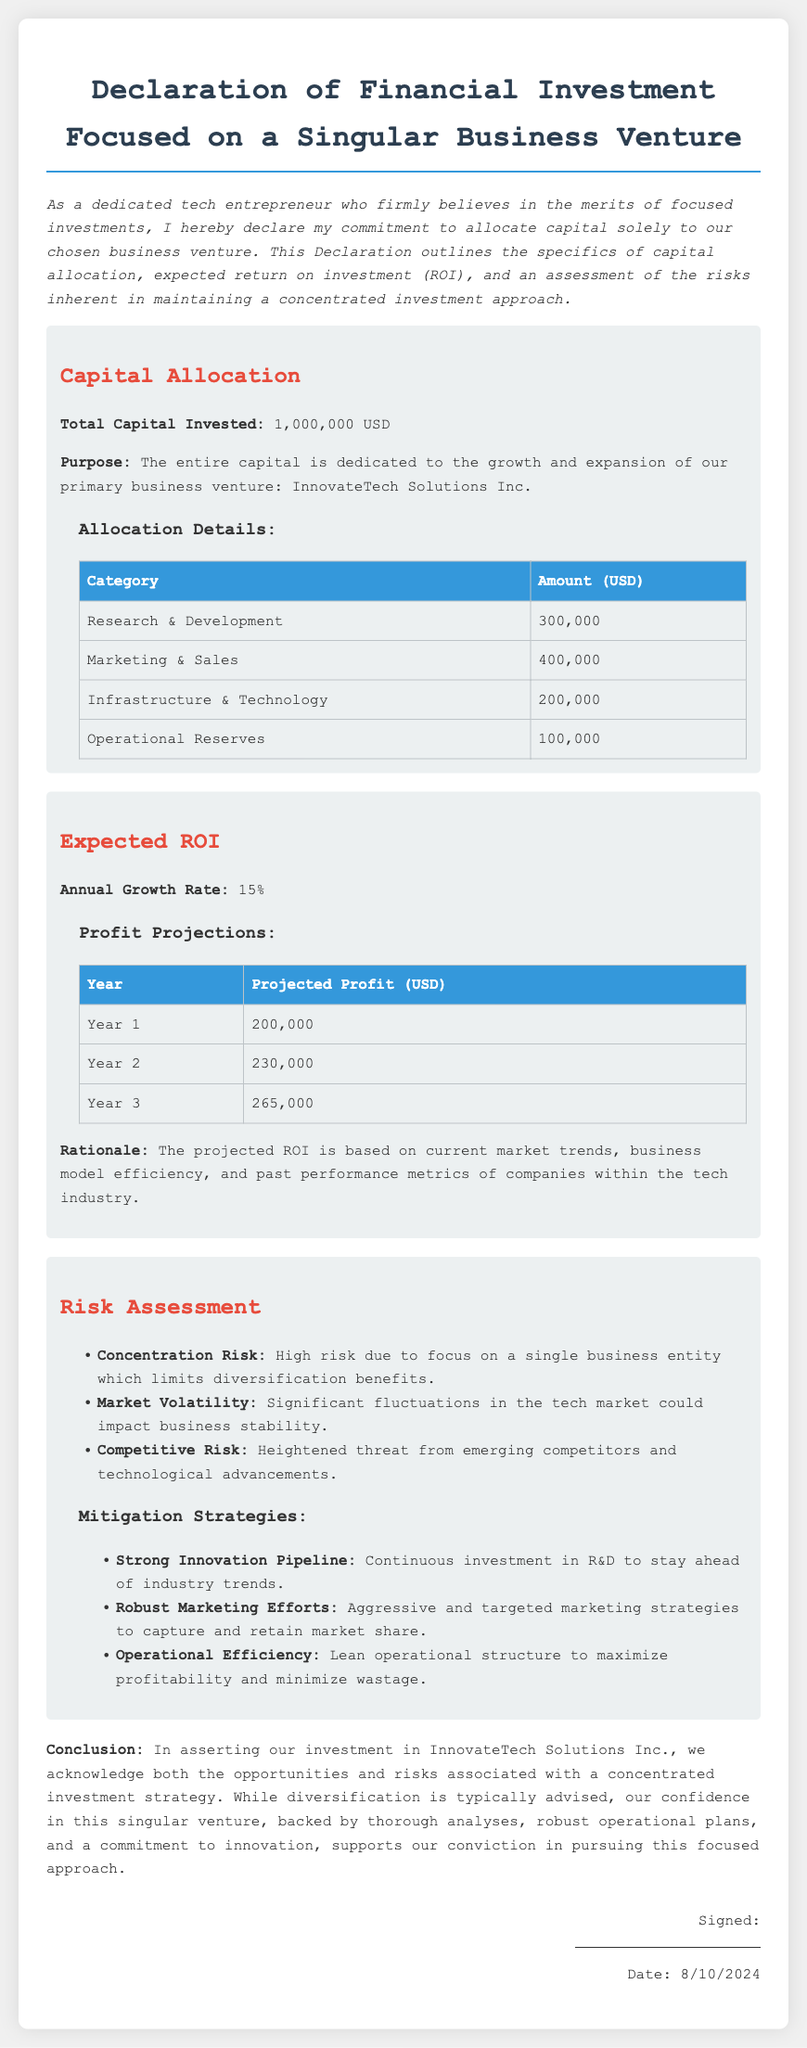What is the total capital invested? The total capital invested is stated explicitly in the document.
Answer: 1,000,000 USD How much is allocated to Research & Development? The allocation details include specific amounts for each category, with R&D listed.
Answer: 300,000 USD What is the expected annual growth rate? The document mentions an annual growth rate that is a key performance indicator for the investment.
Answer: 15% What is the projected profit in Year 2? The profit projections table lists expected profits for each year, including Year 2.
Answer: 230,000 USD What is the main purpose of the capital allocation? The purpose of the capital allocation is clearly defined in the introduction section of the document.
Answer: Growth and expansion of InnovateTech Solutions Inc What is one identified risk in the concentrated investment approach? The risk assessment section lists several risks, and concentration risk is one of them.
Answer: Concentration Risk What strategy is mentioned to mitigate competitive risk? The mitigation strategies outline specific approaches to address different risks, including competitive threats.
Answer: Strong Innovation Pipeline What is the date displayed in the document? The date is dynamically generated in the document and is prominently displayed.
Answer: Current date (as per rendering) 